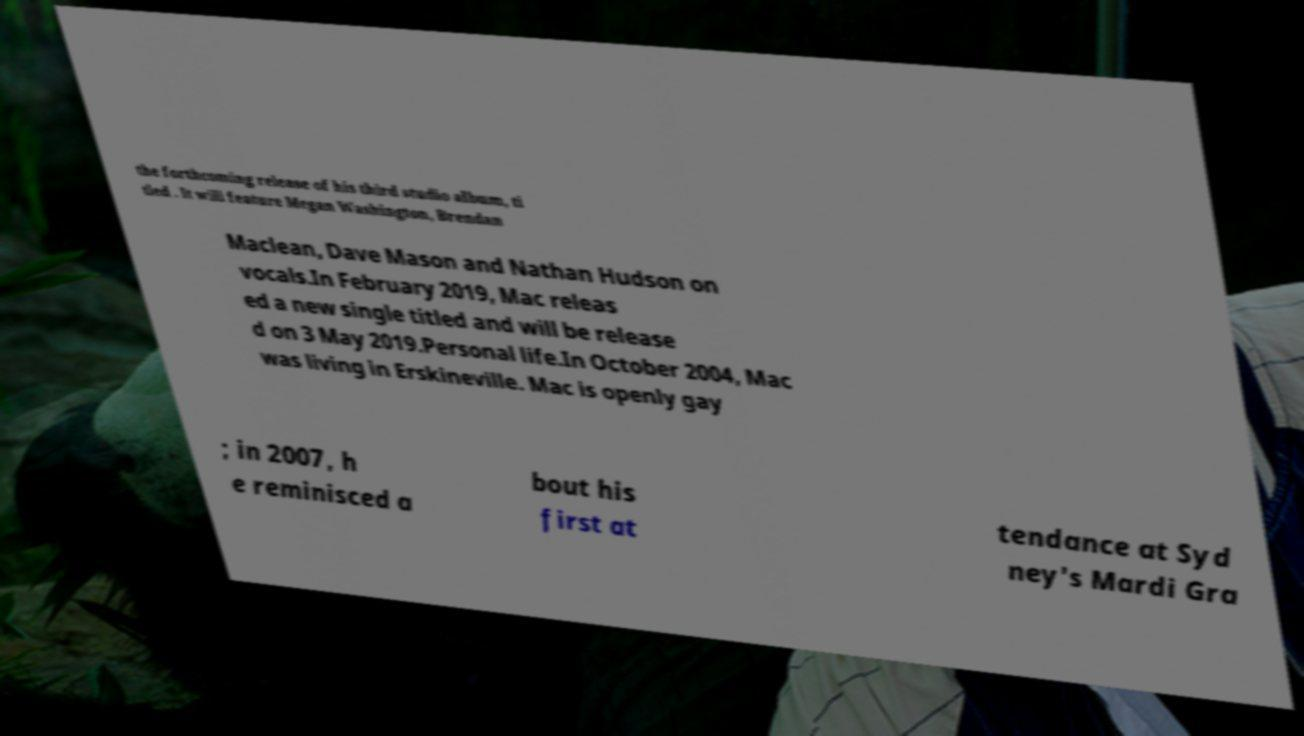Could you extract and type out the text from this image? the forthcoming release of his third studio album, ti tled . It will feature Megan Washington, Brendan Maclean, Dave Mason and Nathan Hudson on vocals.In February 2019, Mac releas ed a new single titled and will be release d on 3 May 2019.Personal life.In October 2004, Mac was living in Erskineville. Mac is openly gay ; in 2007, h e reminisced a bout his first at tendance at Syd ney's Mardi Gra 